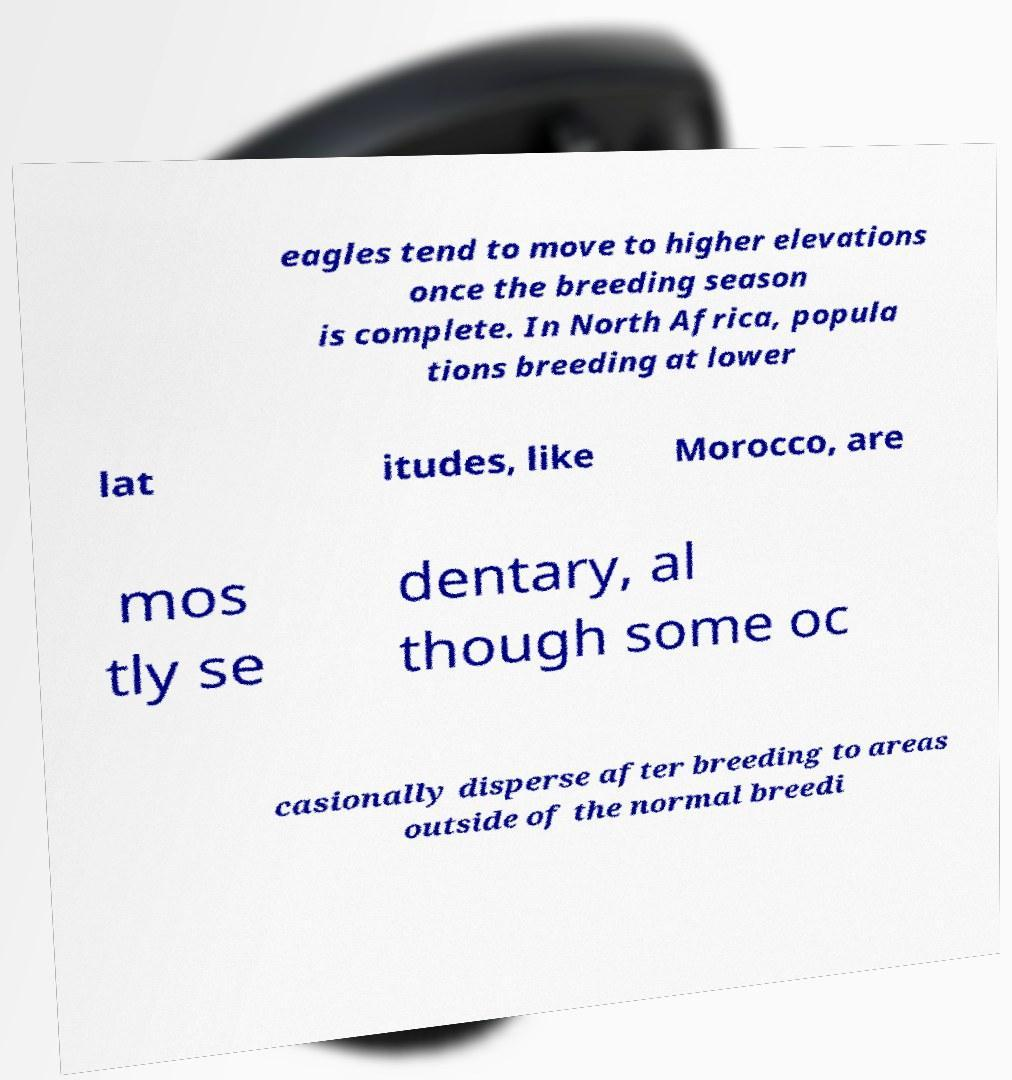Please identify and transcribe the text found in this image. eagles tend to move to higher elevations once the breeding season is complete. In North Africa, popula tions breeding at lower lat itudes, like Morocco, are mos tly se dentary, al though some oc casionally disperse after breeding to areas outside of the normal breedi 